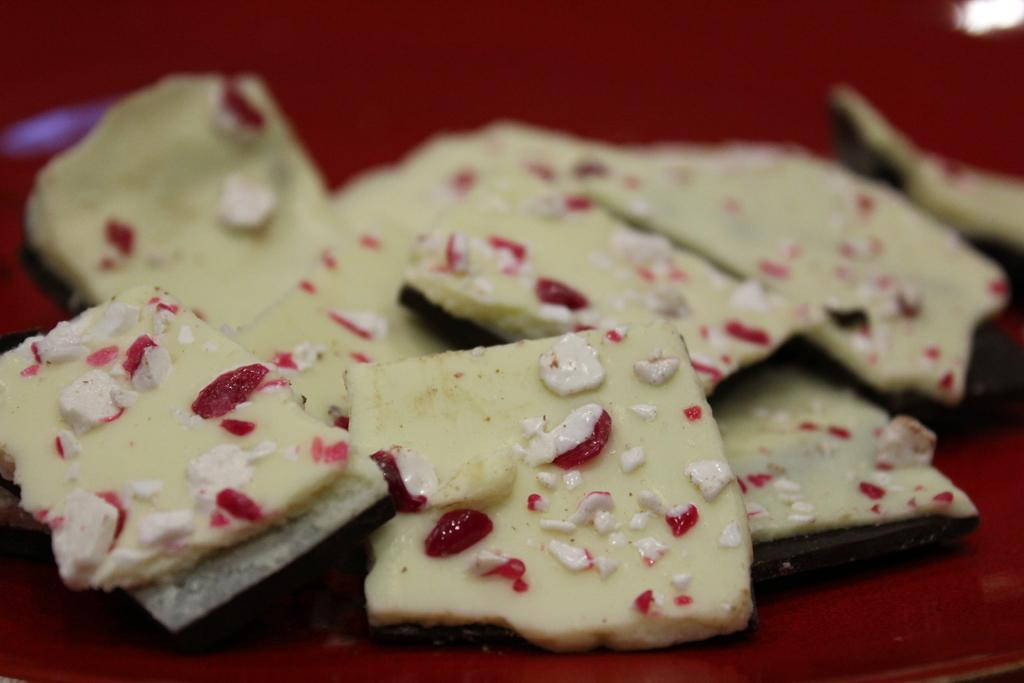What type of food can be seen in the image? The food in the image has cream and red colors. Where is the food located in the image? The food is placed on a table. What is the color of the table in the image? The table has a red color. What type of furniture is the minister using in the image? There is no minister or furniture present in the image. How many trays are visible on the table in the image? There is no tray visible on the table in the image; only the food is present. 